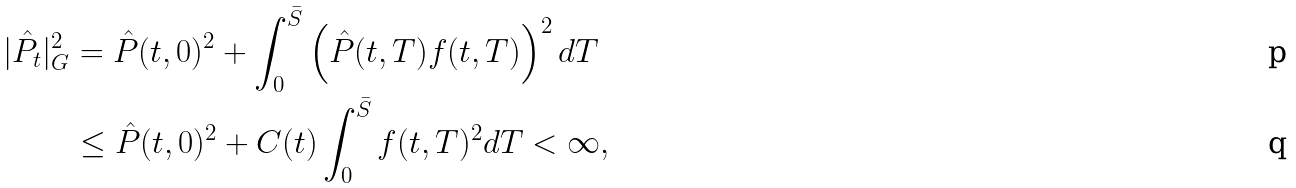<formula> <loc_0><loc_0><loc_500><loc_500>| \hat { P } _ { t } | ^ { 2 } _ { G } & = \hat { P } ( t , 0 ) ^ { 2 } + \int _ { 0 } ^ { \bar { S } } \left ( \hat { P } ( t , T ) f ( t , T ) \right ) ^ { 2 } d T \\ & \leq \hat { P } ( t , 0 ) ^ { 2 } + C ( t ) \int _ { 0 } ^ { \bar { S } } f ( t , T ) ^ { 2 } d T < \infty ,</formula> 